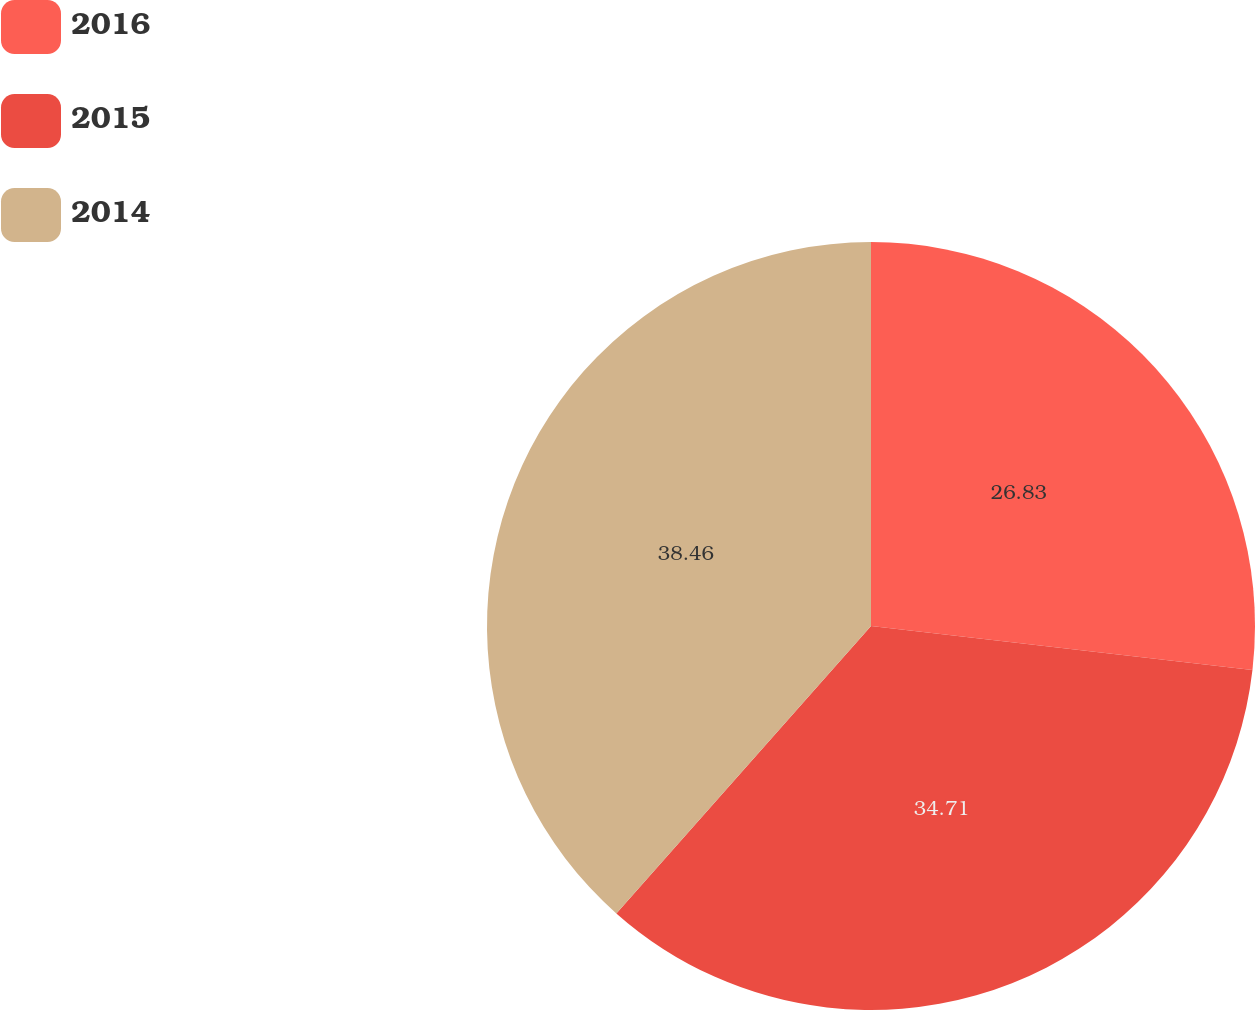Convert chart to OTSL. <chart><loc_0><loc_0><loc_500><loc_500><pie_chart><fcel>2016<fcel>2015<fcel>2014<nl><fcel>26.83%<fcel>34.71%<fcel>38.46%<nl></chart> 